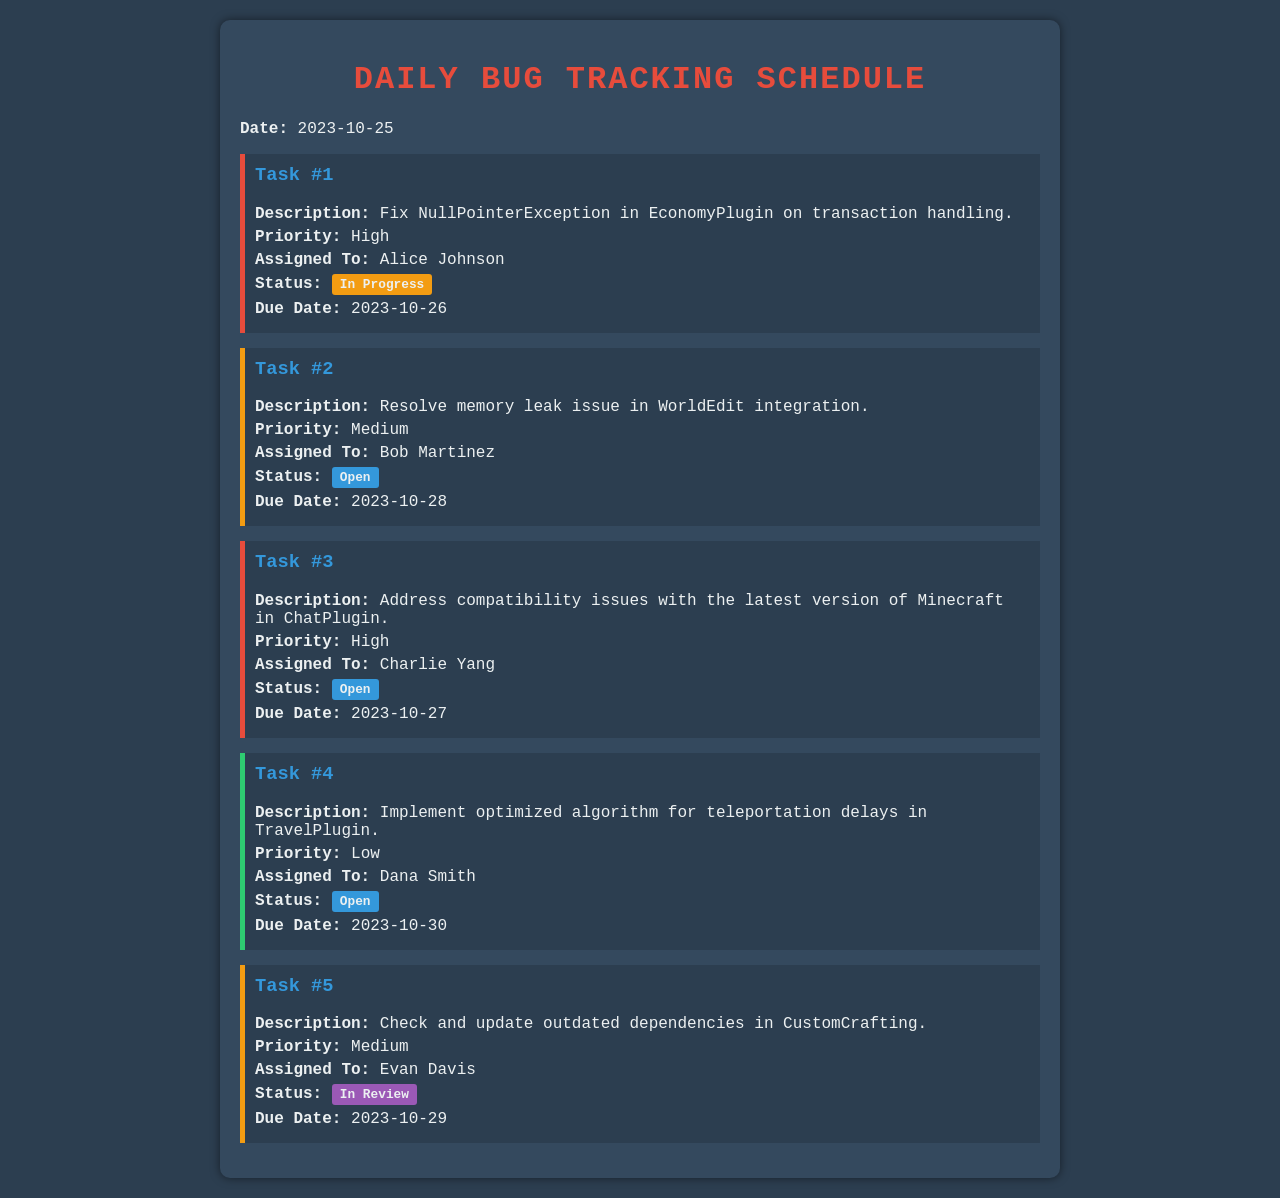What is the due date for Task #1? The due date for Task #1 is specified in the document.
Answer: 2023-10-26 Who is assigned to Task #3? The document clearly states the developer assigned to Task #3.
Answer: Charlie Yang What is the priority level of Task #2? The priority level of Task #2 is mentioned in the task description.
Answer: Medium What is the status of Task #5? The document indicates the current status of Task #5.
Answer: In Review Which task has the highest priority? The document lists tasks by priority, and we can identify the highest.
Answer: Task #1 How many tasks are currently open? By evaluating the task statuses presented, we can determine the number of open tasks.
Answer: 3 What is the description of Task #4? The document provides a detailed description for each task.
Answer: Implement optimized algorithm for teleportation delays in TravelPlugin Who is responsible for fixing the NullPointerException? The document assigns specific developers to each task, indicating responsibility.
Answer: Alice Johnson 